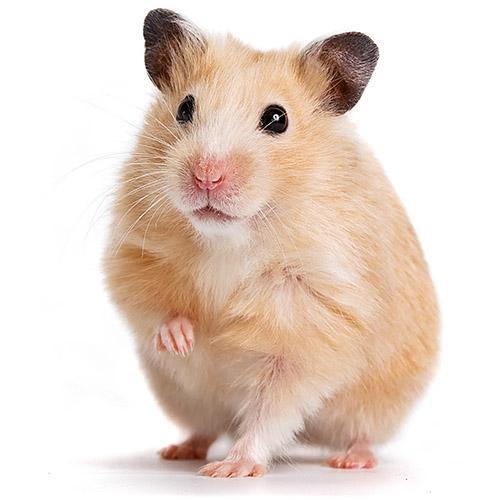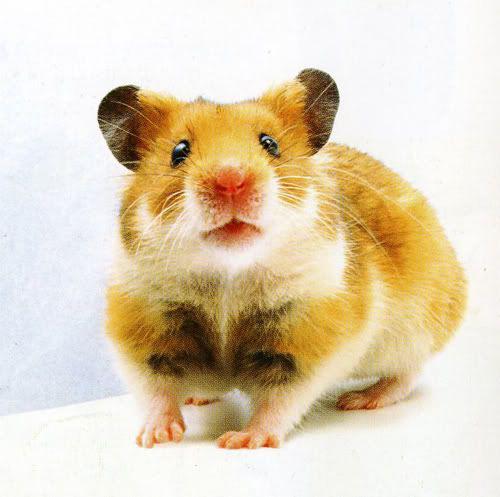The first image is the image on the left, the second image is the image on the right. Given the left and right images, does the statement "The single hamster in one of the images has three feet on the floor and the other raised." hold true? Answer yes or no. Yes. 